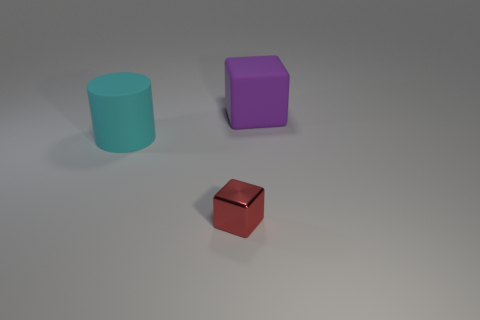Is there anything else that has the same shape as the cyan thing?
Offer a very short reply. No. Is there any other thing that is made of the same material as the small object?
Your answer should be compact. No. Do the big object that is behind the cyan cylinder and the block that is in front of the cyan cylinder have the same material?
Give a very brief answer. No. Are there an equal number of tiny red metallic objects that are on the left side of the cyan cylinder and large cylinders behind the purple matte cube?
Your response must be concise. Yes. What number of small red things are the same material as the red cube?
Your answer should be compact. 0. What is the size of the rubber object in front of the big rubber thing that is on the right side of the small red block?
Offer a very short reply. Large. Is the shape of the rubber thing that is in front of the matte block the same as the thing behind the big cyan thing?
Provide a succinct answer. No. Is the number of big cyan cylinders that are in front of the tiny red metallic thing the same as the number of metallic spheres?
Offer a very short reply. Yes. There is a rubber thing that is the same shape as the shiny object; what color is it?
Offer a very short reply. Purple. Is the material of the large object that is behind the cyan thing the same as the small red cube?
Your answer should be compact. No. 